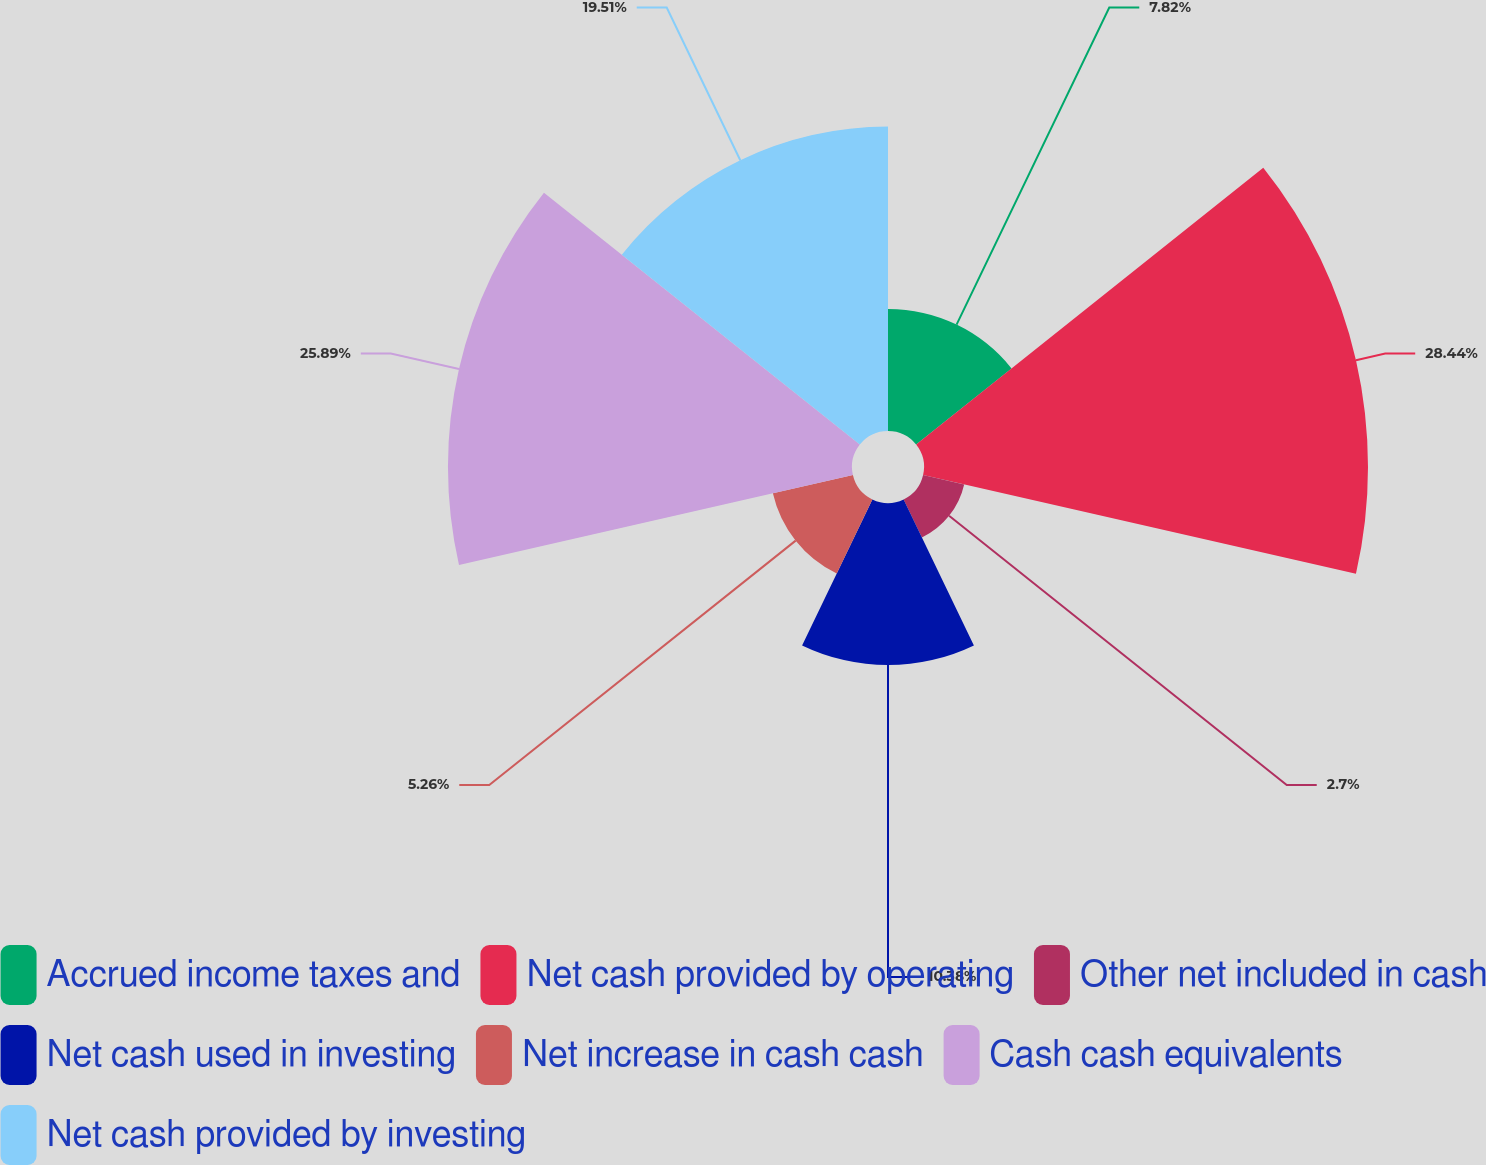Convert chart. <chart><loc_0><loc_0><loc_500><loc_500><pie_chart><fcel>Accrued income taxes and<fcel>Net cash provided by operating<fcel>Other net included in cash<fcel>Net cash used in investing<fcel>Net increase in cash cash<fcel>Cash cash equivalents<fcel>Net cash provided by investing<nl><fcel>7.82%<fcel>28.45%<fcel>2.7%<fcel>10.38%<fcel>5.26%<fcel>25.89%<fcel>19.51%<nl></chart> 